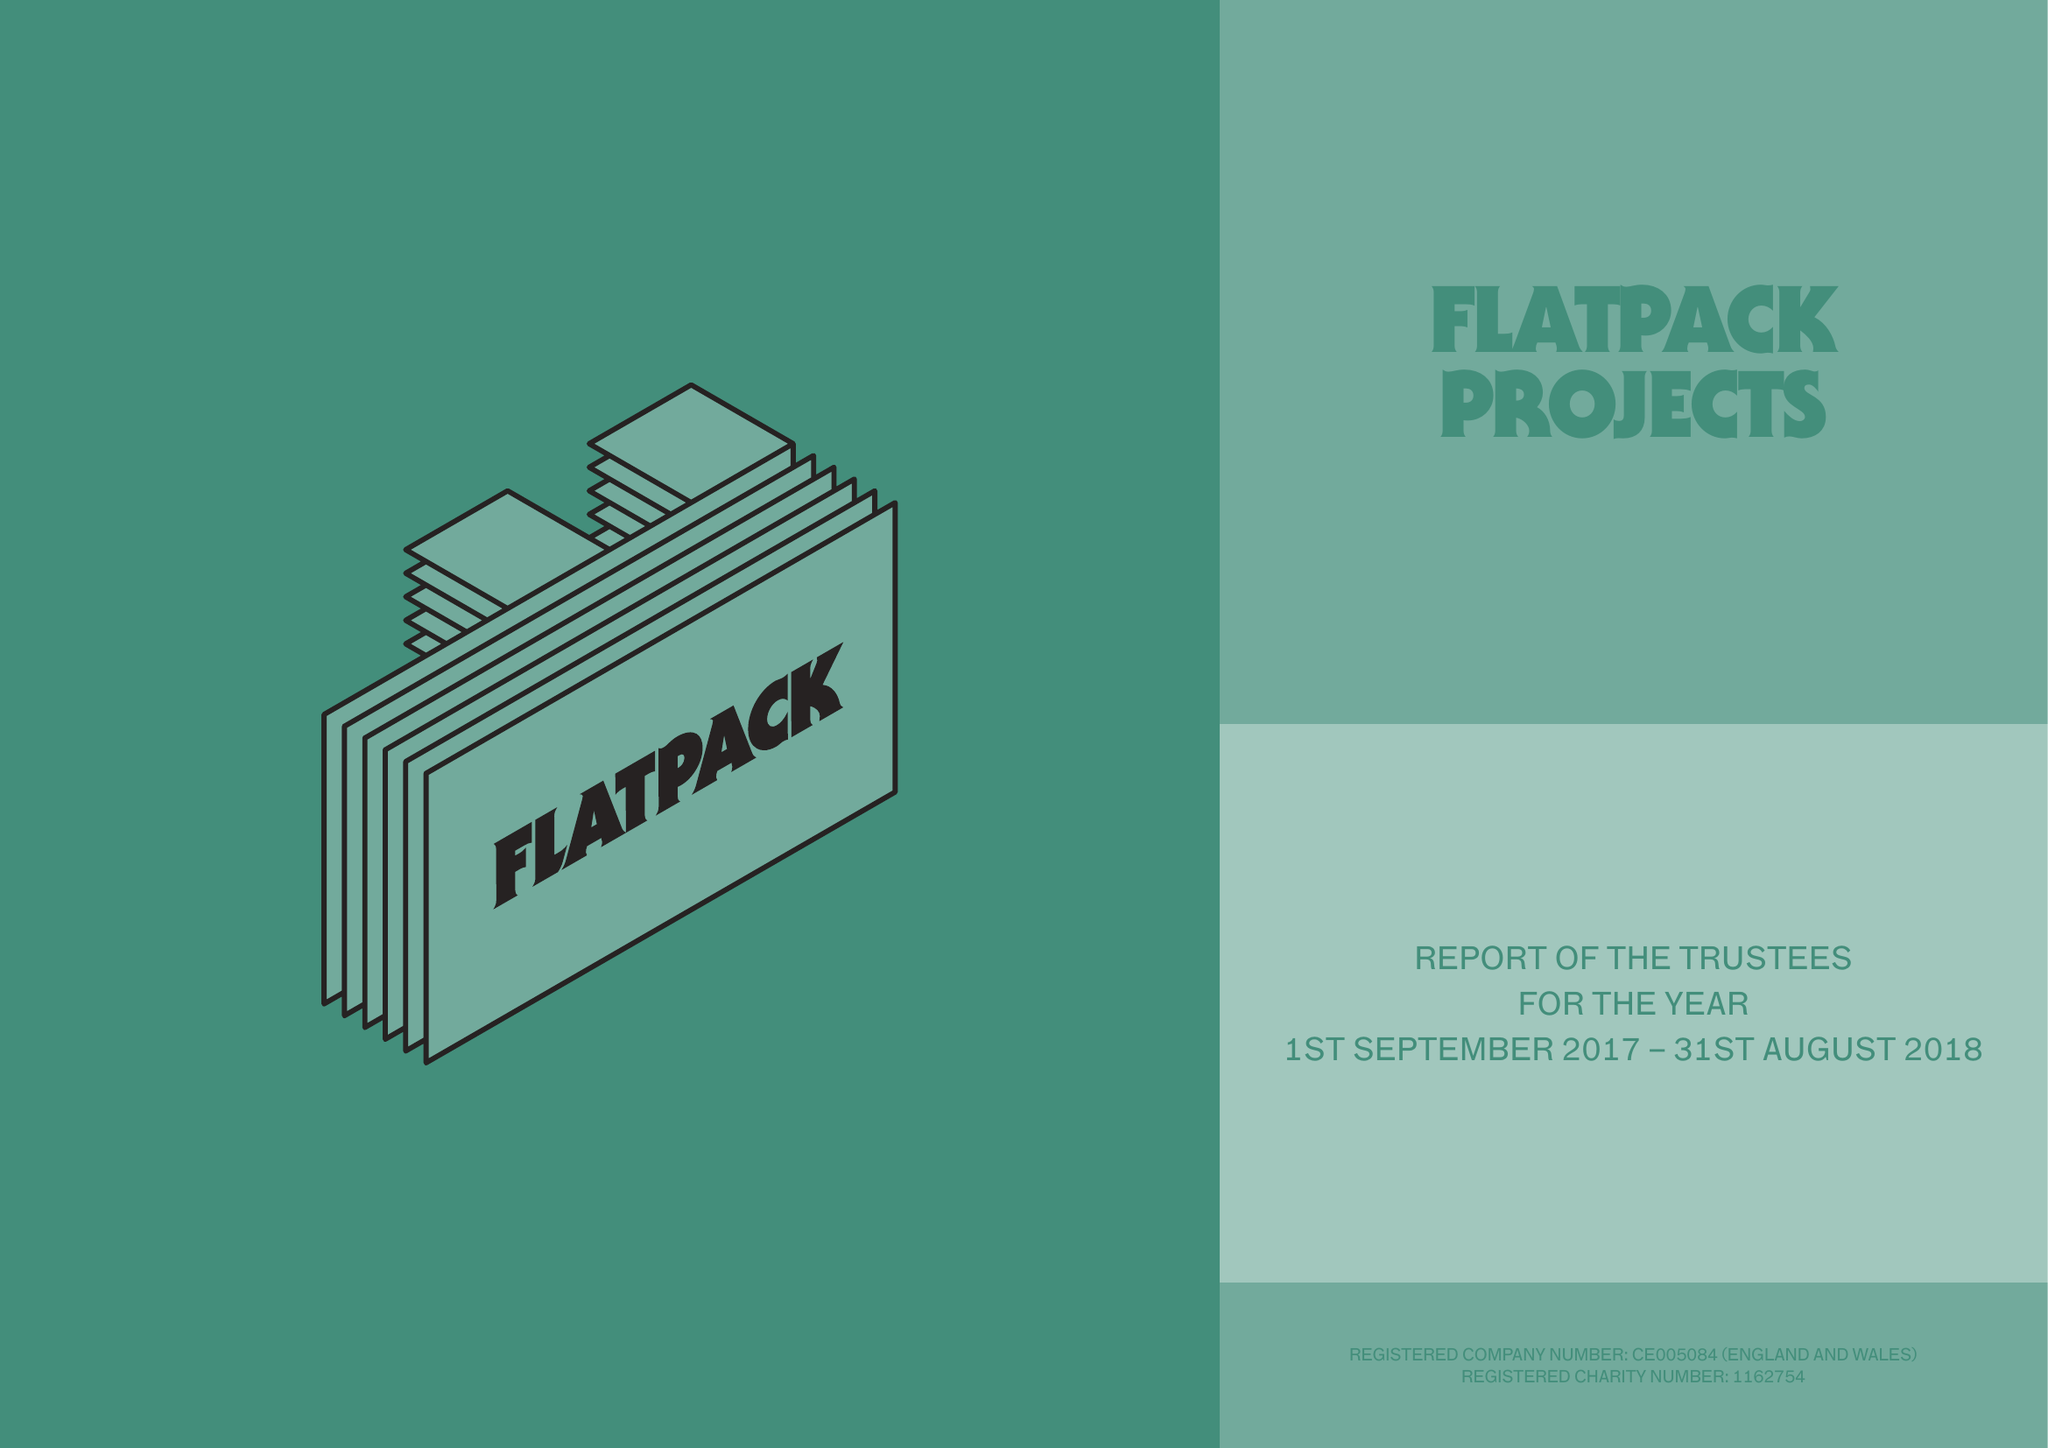What is the value for the spending_annually_in_british_pounds?
Answer the question using a single word or phrase. 426916.00 